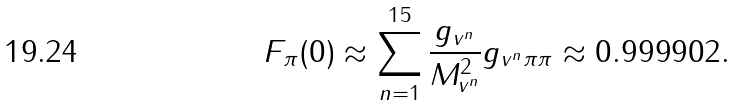Convert formula to latex. <formula><loc_0><loc_0><loc_500><loc_500>F _ { \pi } ( 0 ) \approx \sum _ { n = 1 } ^ { 1 5 } \frac { g _ { v ^ { n } } } { M _ { v ^ { n } } ^ { 2 } } g _ { v ^ { n } \pi \pi } \approx 0 . 9 9 9 9 0 2 .</formula> 